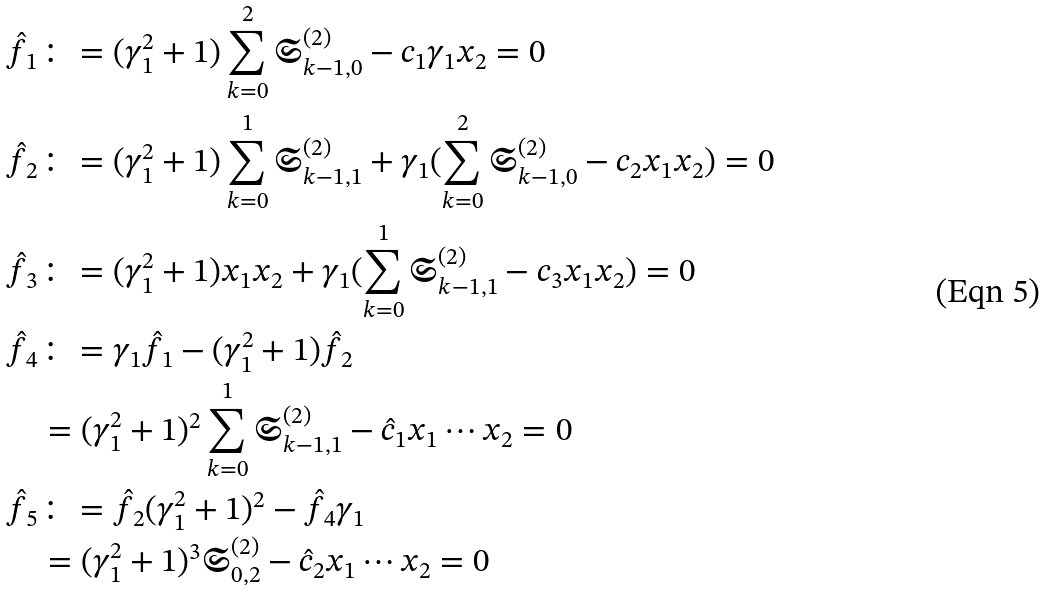<formula> <loc_0><loc_0><loc_500><loc_500>\hat { f } _ { 1 } & \colon = ( \gamma _ { 1 } ^ { 2 } + 1 ) \sum _ { k = 0 } ^ { 2 } \mathfrak { S } ^ { ( 2 ) } _ { k - 1 , 0 } - c _ { 1 } \gamma _ { 1 } x _ { 2 } = 0 \\ \hat { f } _ { 2 } & \colon = ( \gamma _ { 1 } ^ { 2 } + 1 ) \sum _ { k = 0 } ^ { 1 } \mathfrak { S } ^ { ( 2 ) } _ { k - 1 , 1 } + \gamma _ { 1 } ( \sum _ { k = 0 } ^ { 2 } \mathfrak { S } ^ { ( 2 ) } _ { k - 1 , 0 } - c _ { 2 } x _ { 1 } x _ { 2 } ) = 0 \\ \hat { f } _ { 3 } & \colon = ( \gamma _ { 1 } ^ { 2 } + 1 ) x _ { 1 } x _ { 2 } + \gamma _ { 1 } ( \sum _ { k = 0 } ^ { 1 } \mathfrak { S } ^ { ( 2 ) } _ { k - 1 , 1 } - c _ { 3 } x _ { 1 } x _ { 2 } ) = 0 \\ \hat { f } _ { 4 } & \colon = \gamma _ { 1 } \hat { f } _ { 1 } - ( \gamma _ { 1 } ^ { 2 } + 1 ) \hat { f } _ { 2 } \\ & = ( \gamma _ { 1 } ^ { 2 } + 1 ) ^ { 2 } \sum _ { k = 0 } ^ { 1 } \mathfrak { S } ^ { ( 2 ) } _ { k - 1 , 1 } - \hat { c } _ { 1 } x _ { 1 } \cdots x _ { 2 } = 0 \\ \hat { f } _ { 5 } & \colon = \hat { f } _ { 2 } ( \gamma _ { 1 } ^ { 2 } + 1 ) ^ { 2 } - \hat { f } _ { 4 } \gamma _ { 1 } \\ & = ( \gamma _ { 1 } ^ { 2 } + 1 ) ^ { 3 } \mathfrak { S } ^ { ( 2 ) } _ { 0 , 2 } - \hat { c } _ { 2 } x _ { 1 } \cdots x _ { 2 } = 0</formula> 